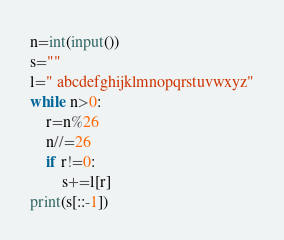Convert code to text. <code><loc_0><loc_0><loc_500><loc_500><_Python_>n=int(input())
s=""
l=" abcdefghijklmnopqrstuvwxyz"
while n>0:
    r=n%26
    n//=26
    if r!=0:
        s+=l[r]
print(s[::-1])
</code> 